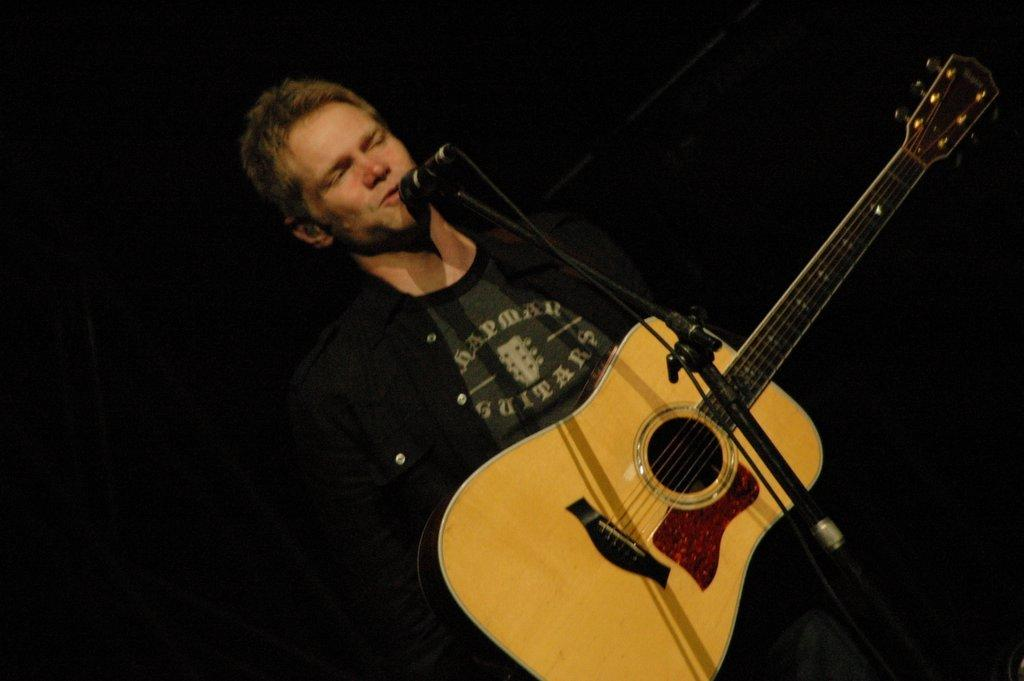What is the main subject of the image? The main subject of the image is a man. What is the man doing in the image? The man is standing, singing, and playing the guitar. What object is the man holding in the image? The man is holding a guitar in the image. What object is near the man's mouth in the image? There is a microphone near the man's mouth in the image. What type of operation is the man performing in the image? There is no operation being performed in the image; the man is singing and playing the guitar. What is the man's current financial status based on the image? The image does not provide any information about the man's financial status, such as debt or wealth. 